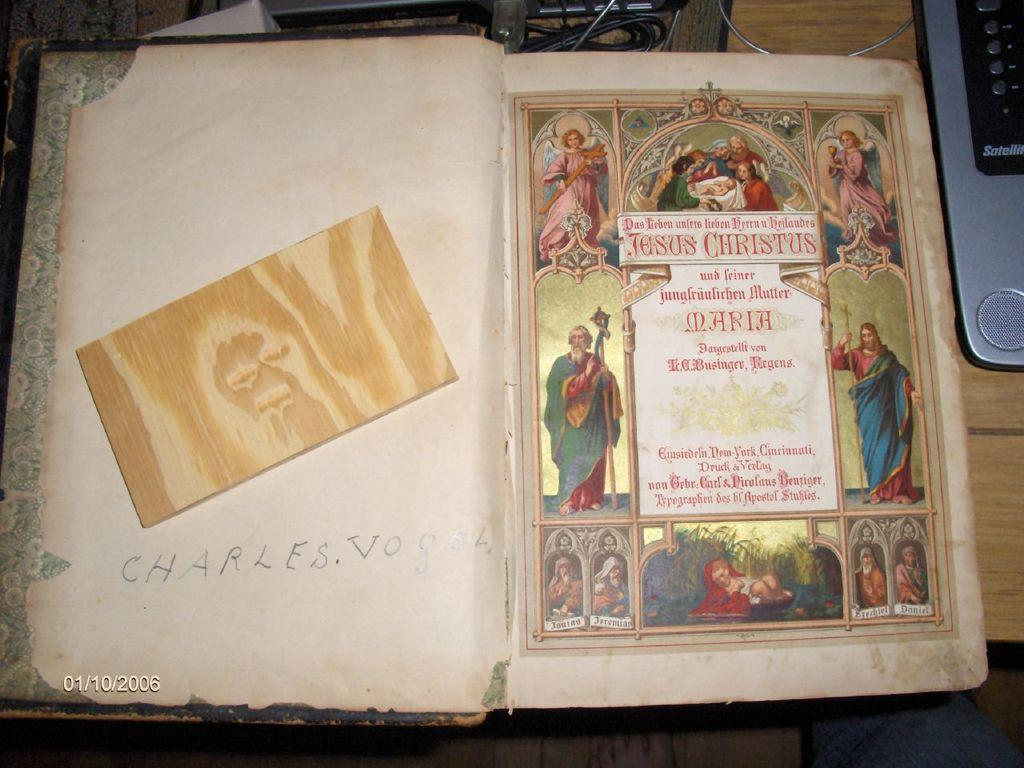<image>
Create a compact narrative representing the image presented. An old book is open to the first page that says Jesus Christus. 